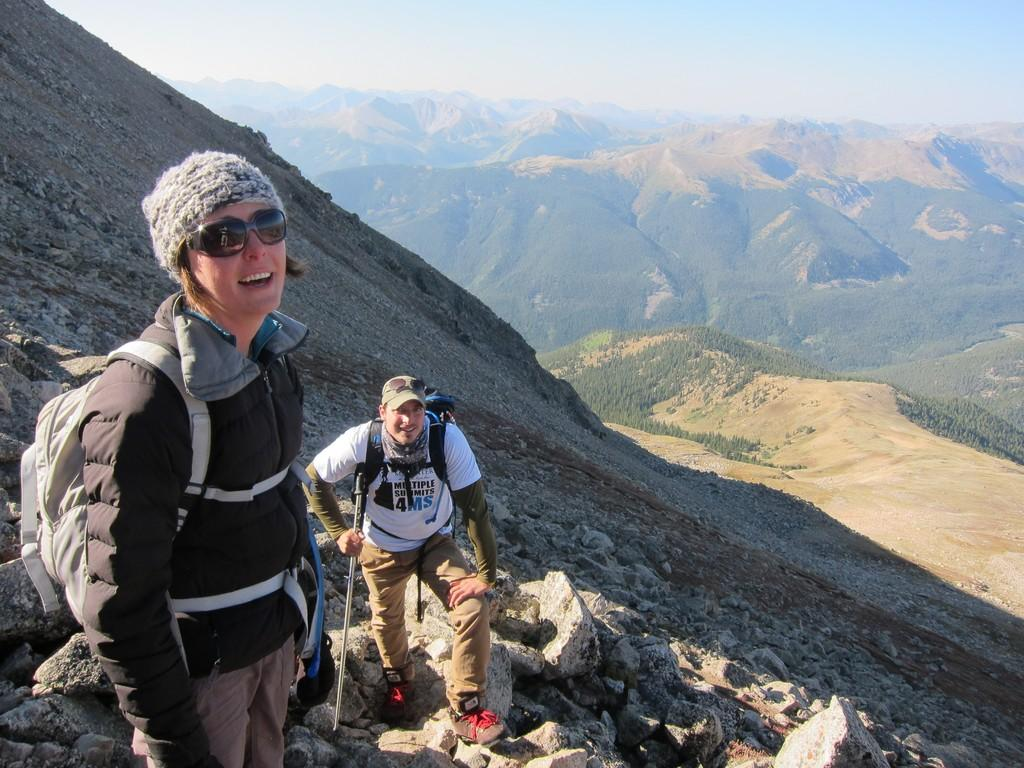How many people are in the image? There are two persons in the image. What are the persons doing in the image? The persons are climbing a hill. What type of clothing are the persons wearing? The persons are wearing coats, caps, and shoes. What can be seen in the background of the image? There are hills in the image. What is visible at the top of the image? The sky is visible at the top of the image. What type of coast can be seen in the image? There is no coast present in the image; it features two persons climbing a hill. How many giants are visible in the image? There are no giants present in the image; it features two persons climbing a hill. 